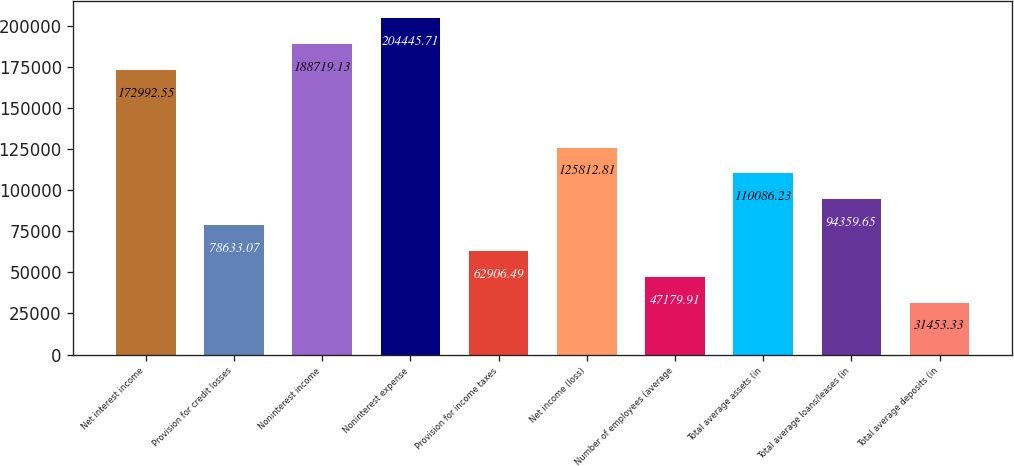Convert chart to OTSL. <chart><loc_0><loc_0><loc_500><loc_500><bar_chart><fcel>Net interest income<fcel>Provision for credit losses<fcel>Noninterest income<fcel>Noninterest expense<fcel>Provision for income taxes<fcel>Net income (loss)<fcel>Number of employees (average<fcel>Total average assets (in<fcel>Total average loans/leases (in<fcel>Total average deposits (in<nl><fcel>172993<fcel>78633.1<fcel>188719<fcel>204446<fcel>62906.5<fcel>125813<fcel>47179.9<fcel>110086<fcel>94359.6<fcel>31453.3<nl></chart> 